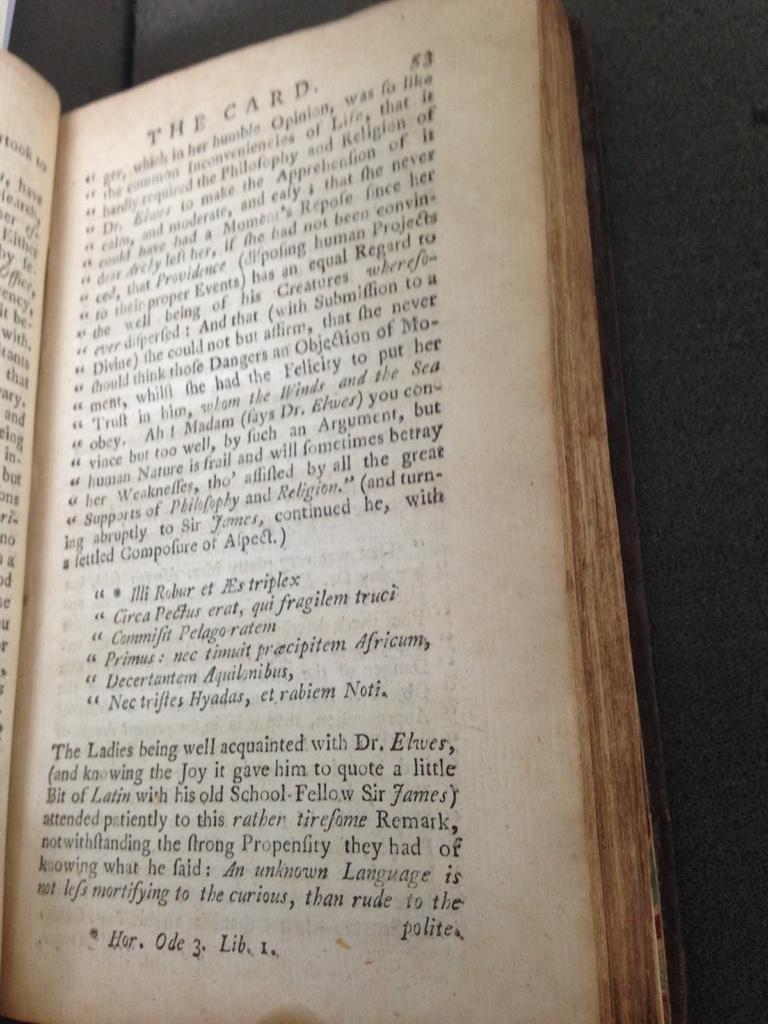<image>
Relay a brief, clear account of the picture shown. An old book with yellowing pages is open to page 53. 